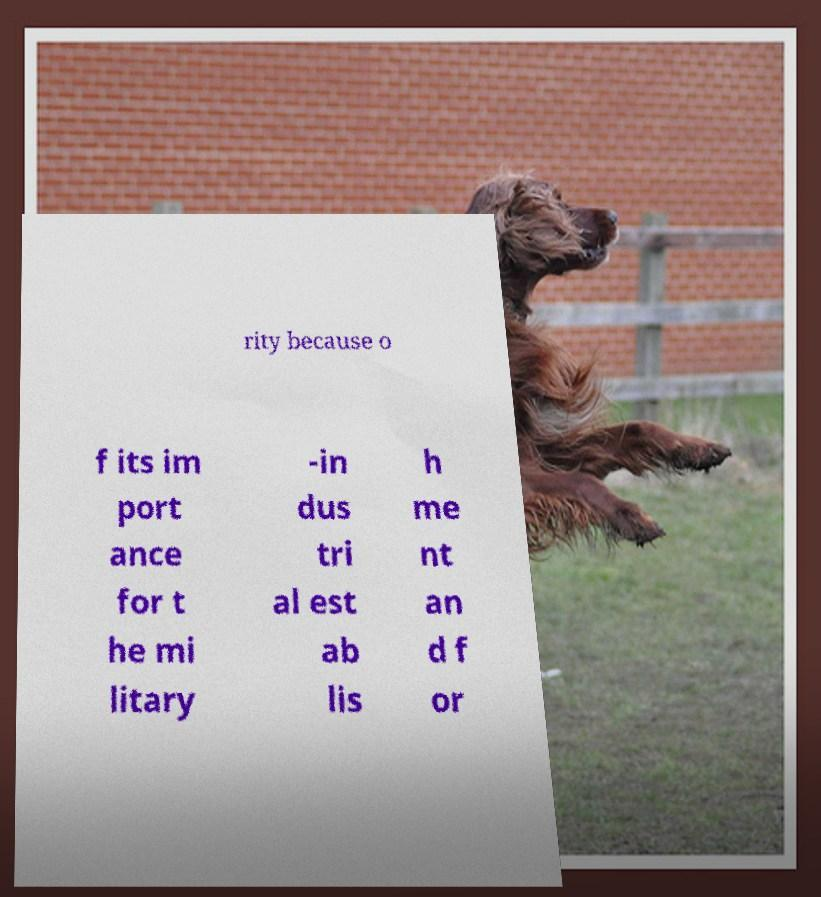Can you read and provide the text displayed in the image?This photo seems to have some interesting text. Can you extract and type it out for me? rity because o f its im port ance for t he mi litary -in dus tri al est ab lis h me nt an d f or 